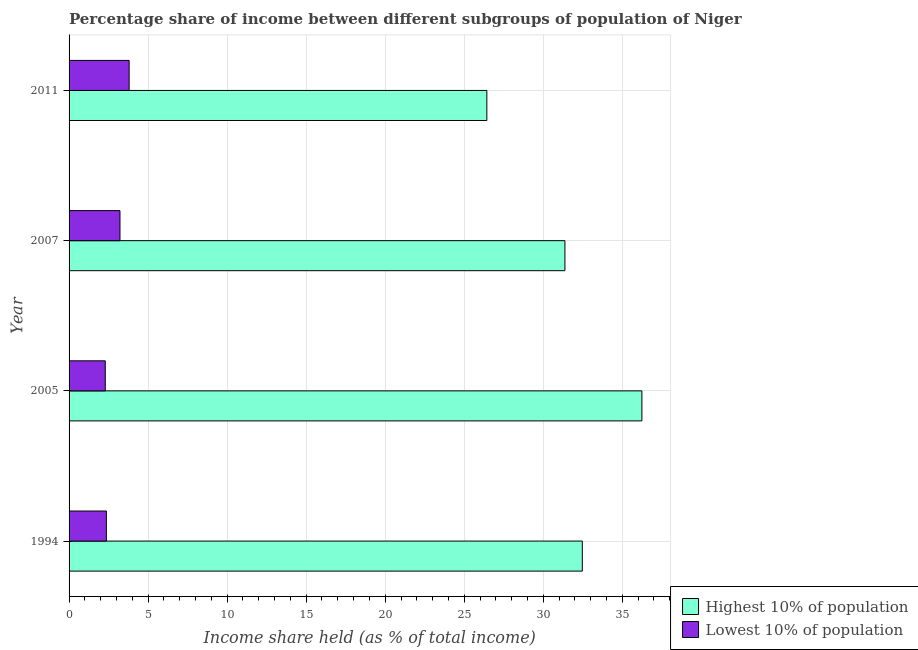Are the number of bars per tick equal to the number of legend labels?
Your answer should be compact. Yes. Are the number of bars on each tick of the Y-axis equal?
Your answer should be very brief. Yes. How many bars are there on the 2nd tick from the top?
Keep it short and to the point. 2. What is the label of the 2nd group of bars from the top?
Ensure brevity in your answer.  2007. In how many cases, is the number of bars for a given year not equal to the number of legend labels?
Offer a terse response. 0. What is the income share held by highest 10% of the population in 1994?
Provide a short and direct response. 32.47. Across all years, what is the maximum income share held by highest 10% of the population?
Your response must be concise. 36.24. Across all years, what is the minimum income share held by lowest 10% of the population?
Your answer should be compact. 2.29. What is the total income share held by lowest 10% of the population in the graph?
Offer a terse response. 11.67. What is the difference between the income share held by lowest 10% of the population in 2007 and that in 2011?
Give a very brief answer. -0.58. What is the difference between the income share held by lowest 10% of the population in 2011 and the income share held by highest 10% of the population in 2007?
Provide a succinct answer. -27.57. What is the average income share held by lowest 10% of the population per year?
Your answer should be very brief. 2.92. In the year 2011, what is the difference between the income share held by highest 10% of the population and income share held by lowest 10% of the population?
Provide a succinct answer. 22.63. In how many years, is the income share held by lowest 10% of the population greater than 6 %?
Make the answer very short. 0. What is the ratio of the income share held by highest 10% of the population in 1994 to that in 2005?
Keep it short and to the point. 0.9. What is the difference between the highest and the second highest income share held by highest 10% of the population?
Your answer should be very brief. 3.77. What is the difference between the highest and the lowest income share held by highest 10% of the population?
Give a very brief answer. 9.81. Is the sum of the income share held by highest 10% of the population in 1994 and 2005 greater than the maximum income share held by lowest 10% of the population across all years?
Provide a short and direct response. Yes. What does the 2nd bar from the top in 1994 represents?
Offer a terse response. Highest 10% of population. What does the 1st bar from the bottom in 2007 represents?
Your response must be concise. Highest 10% of population. How many years are there in the graph?
Your answer should be compact. 4. Does the graph contain any zero values?
Provide a short and direct response. No. Does the graph contain grids?
Give a very brief answer. Yes. Where does the legend appear in the graph?
Your answer should be compact. Bottom right. How many legend labels are there?
Give a very brief answer. 2. What is the title of the graph?
Your answer should be compact. Percentage share of income between different subgroups of population of Niger. What is the label or title of the X-axis?
Ensure brevity in your answer.  Income share held (as % of total income). What is the Income share held (as % of total income) of Highest 10% of population in 1994?
Your response must be concise. 32.47. What is the Income share held (as % of total income) of Lowest 10% of population in 1994?
Offer a very short reply. 2.36. What is the Income share held (as % of total income) in Highest 10% of population in 2005?
Offer a very short reply. 36.24. What is the Income share held (as % of total income) of Lowest 10% of population in 2005?
Your answer should be very brief. 2.29. What is the Income share held (as % of total income) in Highest 10% of population in 2007?
Give a very brief answer. 31.37. What is the Income share held (as % of total income) in Lowest 10% of population in 2007?
Provide a succinct answer. 3.22. What is the Income share held (as % of total income) of Highest 10% of population in 2011?
Give a very brief answer. 26.43. What is the Income share held (as % of total income) in Lowest 10% of population in 2011?
Keep it short and to the point. 3.8. Across all years, what is the maximum Income share held (as % of total income) in Highest 10% of population?
Give a very brief answer. 36.24. Across all years, what is the minimum Income share held (as % of total income) of Highest 10% of population?
Offer a very short reply. 26.43. Across all years, what is the minimum Income share held (as % of total income) of Lowest 10% of population?
Provide a succinct answer. 2.29. What is the total Income share held (as % of total income) in Highest 10% of population in the graph?
Offer a very short reply. 126.51. What is the total Income share held (as % of total income) of Lowest 10% of population in the graph?
Your answer should be very brief. 11.67. What is the difference between the Income share held (as % of total income) of Highest 10% of population in 1994 and that in 2005?
Your answer should be compact. -3.77. What is the difference between the Income share held (as % of total income) in Lowest 10% of population in 1994 and that in 2005?
Ensure brevity in your answer.  0.07. What is the difference between the Income share held (as % of total income) of Highest 10% of population in 1994 and that in 2007?
Offer a terse response. 1.1. What is the difference between the Income share held (as % of total income) of Lowest 10% of population in 1994 and that in 2007?
Give a very brief answer. -0.86. What is the difference between the Income share held (as % of total income) of Highest 10% of population in 1994 and that in 2011?
Ensure brevity in your answer.  6.04. What is the difference between the Income share held (as % of total income) of Lowest 10% of population in 1994 and that in 2011?
Your answer should be very brief. -1.44. What is the difference between the Income share held (as % of total income) in Highest 10% of population in 2005 and that in 2007?
Your answer should be very brief. 4.87. What is the difference between the Income share held (as % of total income) in Lowest 10% of population in 2005 and that in 2007?
Give a very brief answer. -0.93. What is the difference between the Income share held (as % of total income) in Highest 10% of population in 2005 and that in 2011?
Ensure brevity in your answer.  9.81. What is the difference between the Income share held (as % of total income) in Lowest 10% of population in 2005 and that in 2011?
Ensure brevity in your answer.  -1.51. What is the difference between the Income share held (as % of total income) of Highest 10% of population in 2007 and that in 2011?
Give a very brief answer. 4.94. What is the difference between the Income share held (as % of total income) in Lowest 10% of population in 2007 and that in 2011?
Provide a short and direct response. -0.58. What is the difference between the Income share held (as % of total income) in Highest 10% of population in 1994 and the Income share held (as % of total income) in Lowest 10% of population in 2005?
Give a very brief answer. 30.18. What is the difference between the Income share held (as % of total income) in Highest 10% of population in 1994 and the Income share held (as % of total income) in Lowest 10% of population in 2007?
Give a very brief answer. 29.25. What is the difference between the Income share held (as % of total income) of Highest 10% of population in 1994 and the Income share held (as % of total income) of Lowest 10% of population in 2011?
Provide a succinct answer. 28.67. What is the difference between the Income share held (as % of total income) of Highest 10% of population in 2005 and the Income share held (as % of total income) of Lowest 10% of population in 2007?
Ensure brevity in your answer.  33.02. What is the difference between the Income share held (as % of total income) in Highest 10% of population in 2005 and the Income share held (as % of total income) in Lowest 10% of population in 2011?
Offer a very short reply. 32.44. What is the difference between the Income share held (as % of total income) of Highest 10% of population in 2007 and the Income share held (as % of total income) of Lowest 10% of population in 2011?
Ensure brevity in your answer.  27.57. What is the average Income share held (as % of total income) in Highest 10% of population per year?
Provide a succinct answer. 31.63. What is the average Income share held (as % of total income) of Lowest 10% of population per year?
Offer a very short reply. 2.92. In the year 1994, what is the difference between the Income share held (as % of total income) of Highest 10% of population and Income share held (as % of total income) of Lowest 10% of population?
Offer a terse response. 30.11. In the year 2005, what is the difference between the Income share held (as % of total income) of Highest 10% of population and Income share held (as % of total income) of Lowest 10% of population?
Make the answer very short. 33.95. In the year 2007, what is the difference between the Income share held (as % of total income) in Highest 10% of population and Income share held (as % of total income) in Lowest 10% of population?
Your answer should be compact. 28.15. In the year 2011, what is the difference between the Income share held (as % of total income) in Highest 10% of population and Income share held (as % of total income) in Lowest 10% of population?
Provide a short and direct response. 22.63. What is the ratio of the Income share held (as % of total income) in Highest 10% of population in 1994 to that in 2005?
Your answer should be very brief. 0.9. What is the ratio of the Income share held (as % of total income) in Lowest 10% of population in 1994 to that in 2005?
Ensure brevity in your answer.  1.03. What is the ratio of the Income share held (as % of total income) in Highest 10% of population in 1994 to that in 2007?
Ensure brevity in your answer.  1.04. What is the ratio of the Income share held (as % of total income) in Lowest 10% of population in 1994 to that in 2007?
Offer a very short reply. 0.73. What is the ratio of the Income share held (as % of total income) in Highest 10% of population in 1994 to that in 2011?
Keep it short and to the point. 1.23. What is the ratio of the Income share held (as % of total income) in Lowest 10% of population in 1994 to that in 2011?
Offer a very short reply. 0.62. What is the ratio of the Income share held (as % of total income) in Highest 10% of population in 2005 to that in 2007?
Ensure brevity in your answer.  1.16. What is the ratio of the Income share held (as % of total income) of Lowest 10% of population in 2005 to that in 2007?
Offer a very short reply. 0.71. What is the ratio of the Income share held (as % of total income) of Highest 10% of population in 2005 to that in 2011?
Your answer should be compact. 1.37. What is the ratio of the Income share held (as % of total income) in Lowest 10% of population in 2005 to that in 2011?
Provide a short and direct response. 0.6. What is the ratio of the Income share held (as % of total income) of Highest 10% of population in 2007 to that in 2011?
Your answer should be compact. 1.19. What is the ratio of the Income share held (as % of total income) of Lowest 10% of population in 2007 to that in 2011?
Offer a very short reply. 0.85. What is the difference between the highest and the second highest Income share held (as % of total income) in Highest 10% of population?
Keep it short and to the point. 3.77. What is the difference between the highest and the second highest Income share held (as % of total income) of Lowest 10% of population?
Provide a succinct answer. 0.58. What is the difference between the highest and the lowest Income share held (as % of total income) in Highest 10% of population?
Offer a terse response. 9.81. What is the difference between the highest and the lowest Income share held (as % of total income) in Lowest 10% of population?
Give a very brief answer. 1.51. 